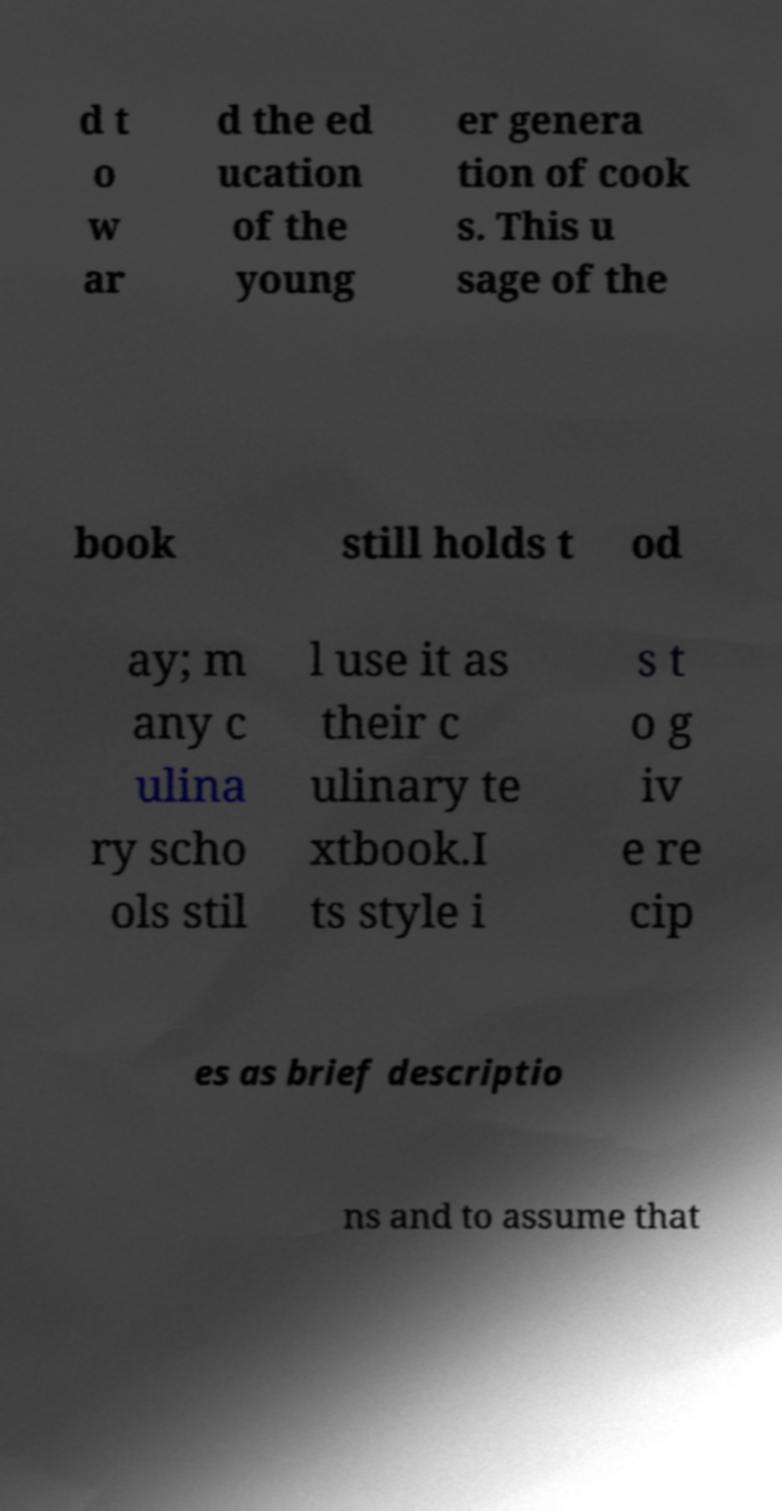Please read and relay the text visible in this image. What does it say? d t o w ar d the ed ucation of the young er genera tion of cook s. This u sage of the book still holds t od ay; m any c ulina ry scho ols stil l use it as their c ulinary te xtbook.I ts style i s t o g iv e re cip es as brief descriptio ns and to assume that 